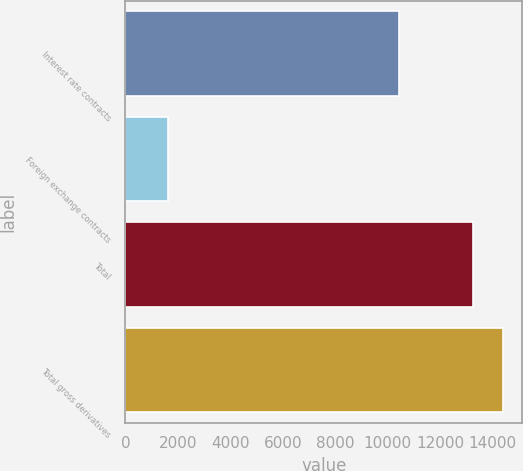<chart> <loc_0><loc_0><loc_500><loc_500><bar_chart><fcel>Interest rate contracts<fcel>Foreign exchange contracts<fcel>Total<fcel>Total gross derivatives<nl><fcel>10446<fcel>1619<fcel>13251<fcel>14419.8<nl></chart> 